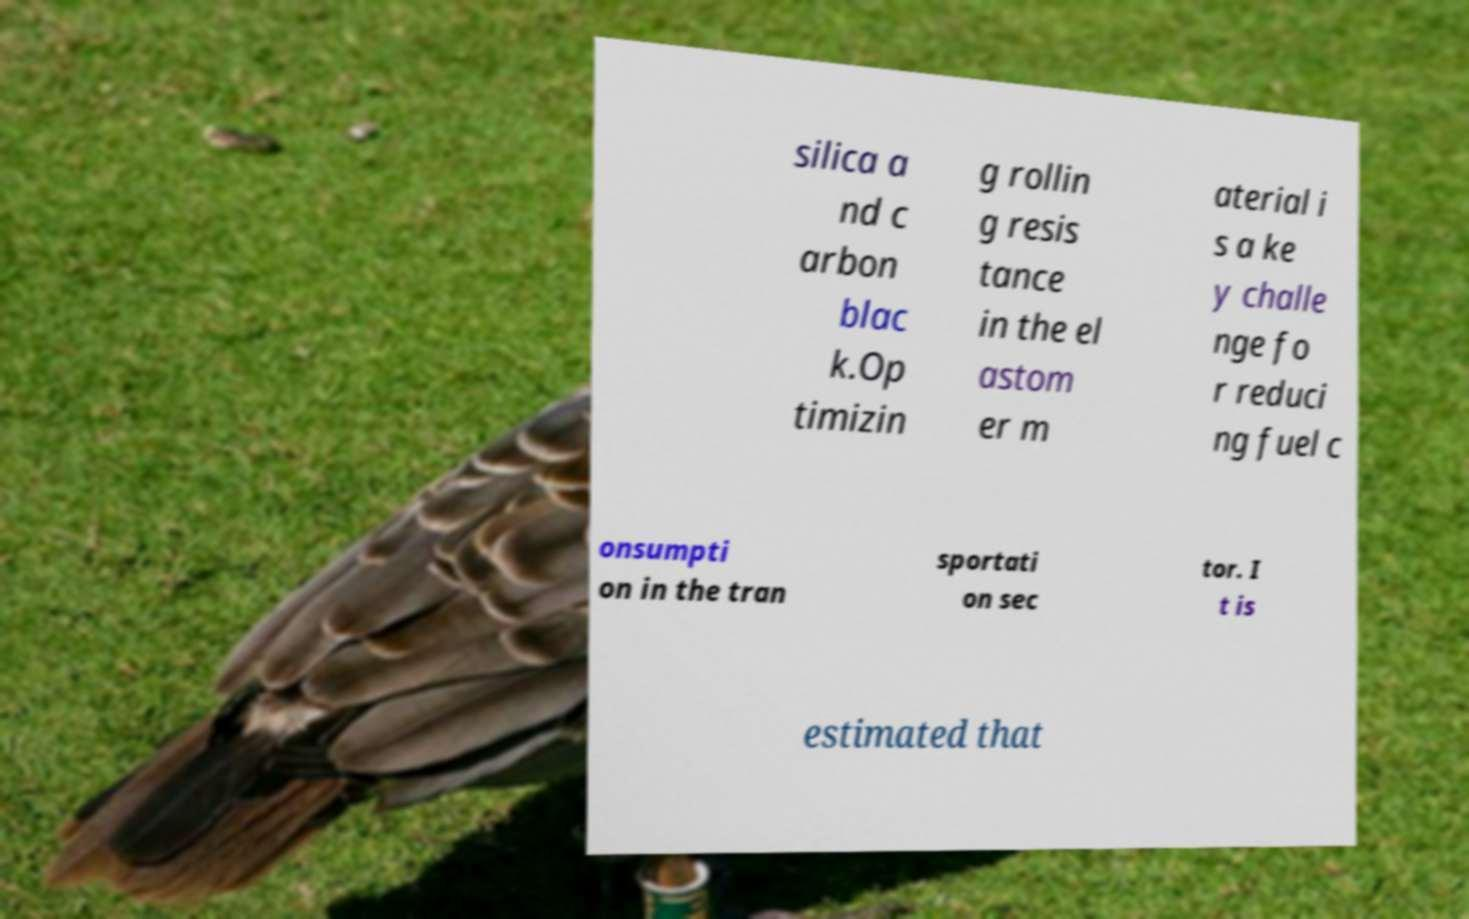Could you extract and type out the text from this image? silica a nd c arbon blac k.Op timizin g rollin g resis tance in the el astom er m aterial i s a ke y challe nge fo r reduci ng fuel c onsumpti on in the tran sportati on sec tor. I t is estimated that 